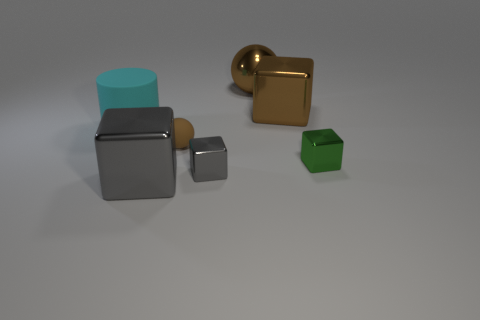There is a shiny thing that is the same color as the large sphere; what is its shape? The shiny object that shares the same gold color as the large sphere is in fact shaped like a cube. This geometric clarity, along with the reflective surface, provides a stark contrast to the smooth and round sphere. 